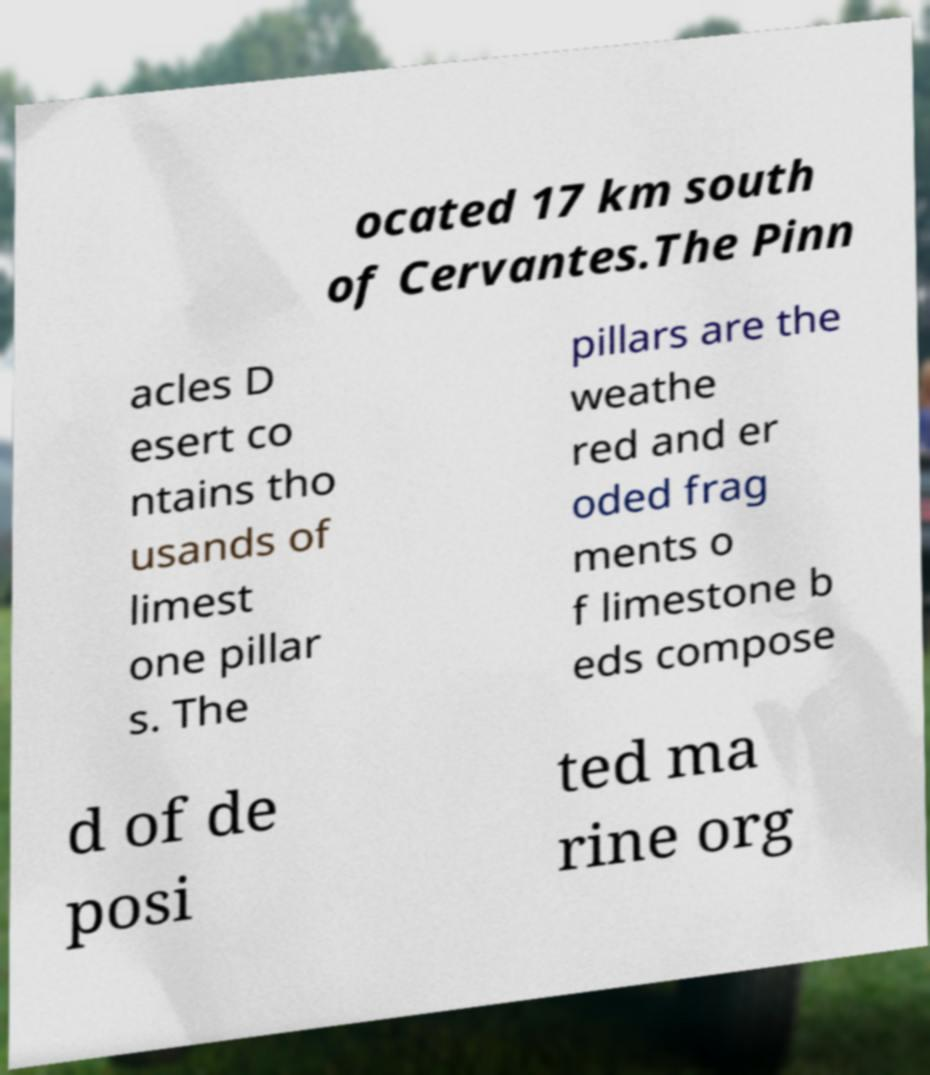Could you extract and type out the text from this image? ocated 17 km south of Cervantes.The Pinn acles D esert co ntains tho usands of limest one pillar s. The pillars are the weathe red and er oded frag ments o f limestone b eds compose d of de posi ted ma rine org 